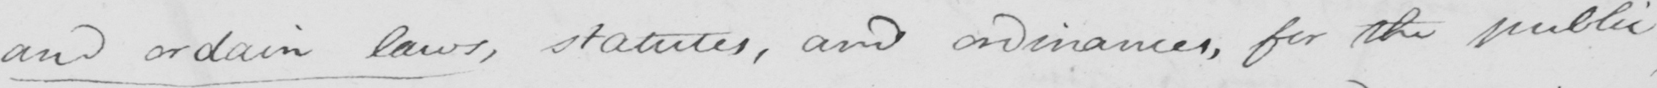Transcribe the text shown in this historical manuscript line. and ordain laws , statutes , and ordinances , for the public 